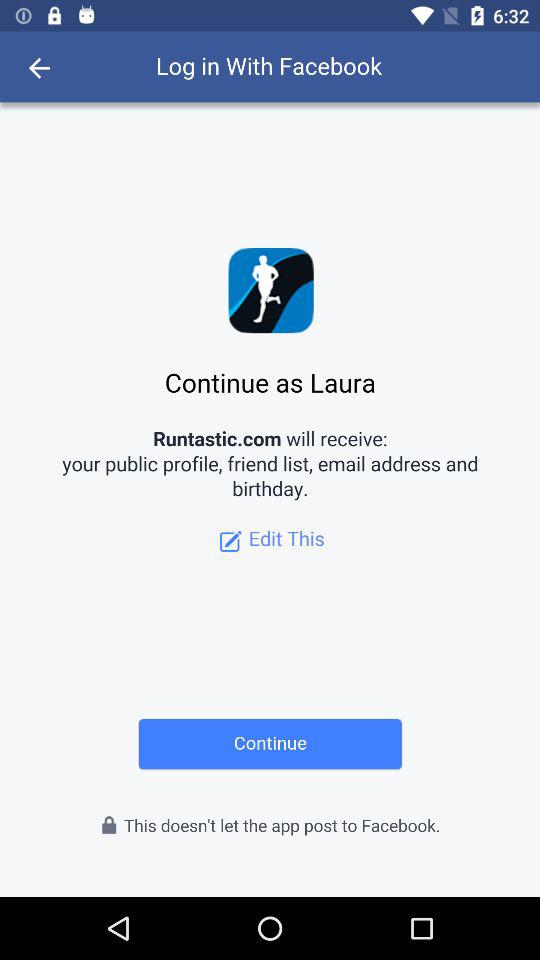What application is asking for permission? The application is "Runtastic.com". 